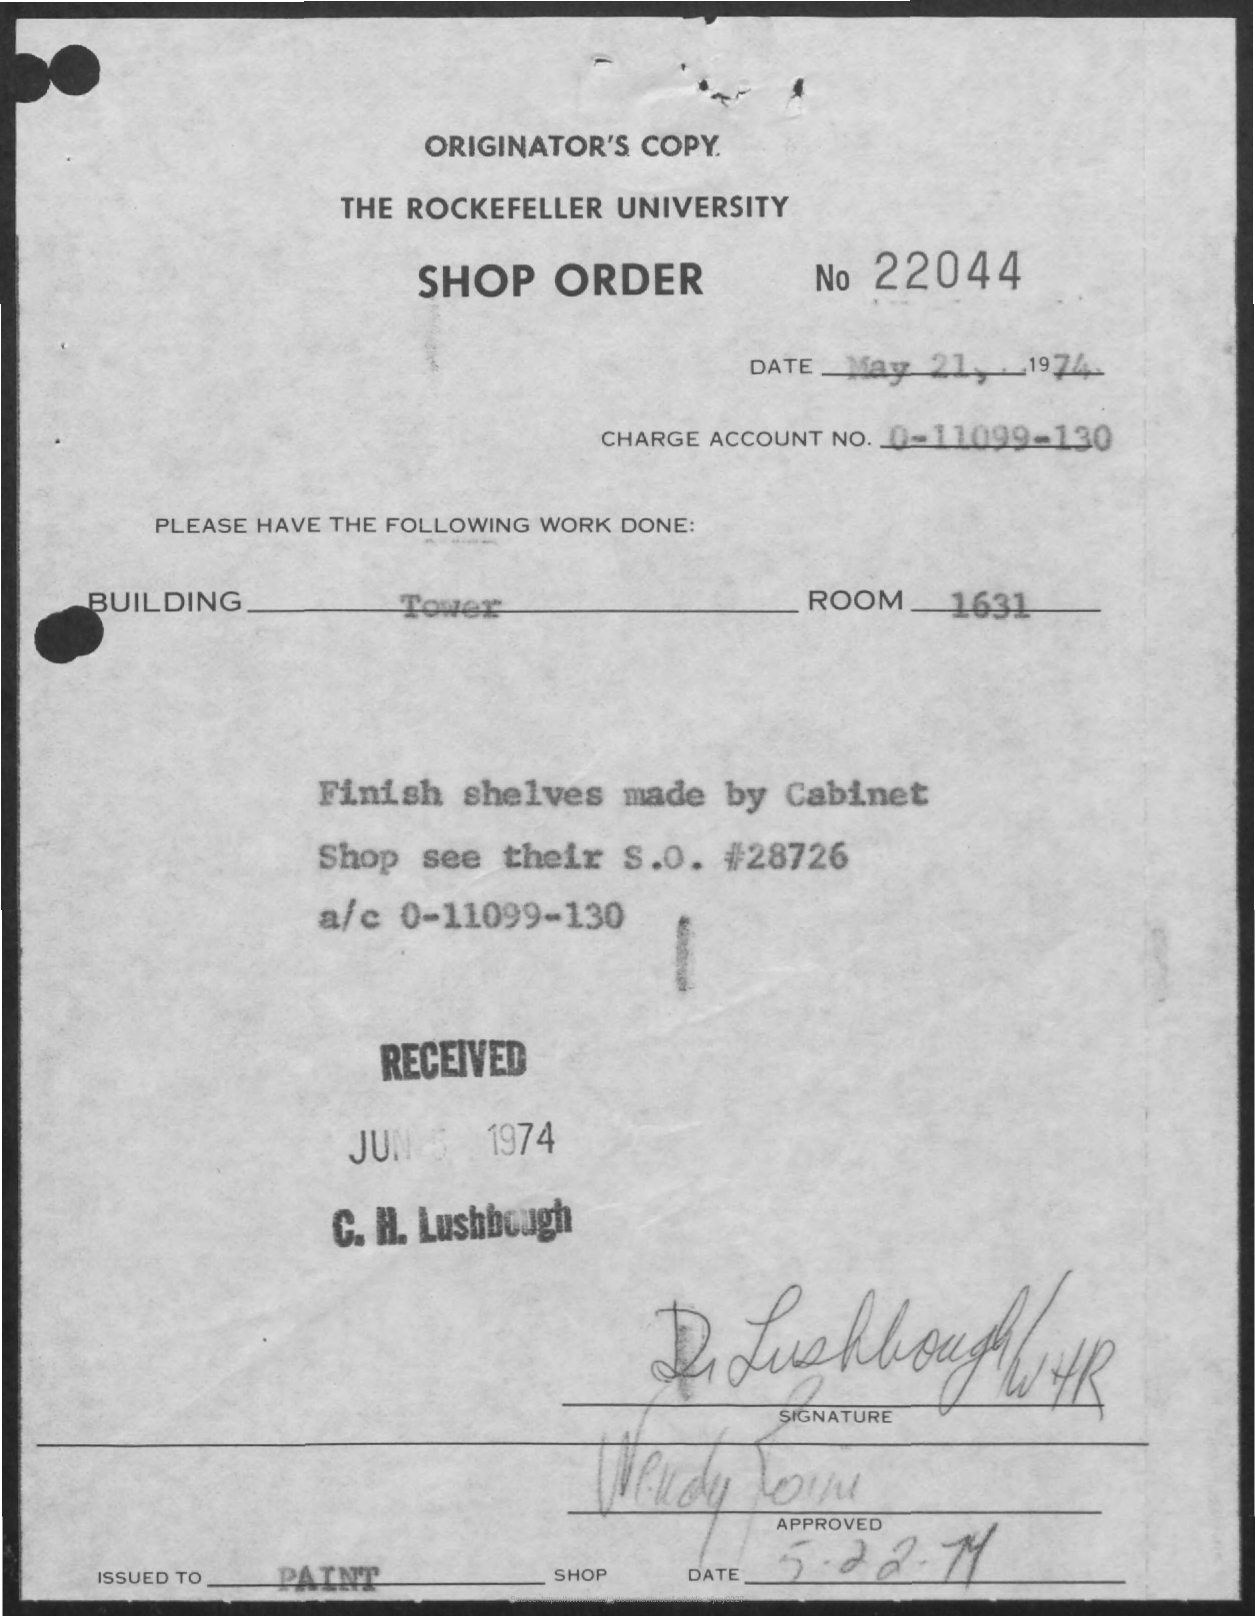What is the Charge Account Number?
Offer a very short reply. 0-11099-130. What is the Room Number?
Your response must be concise. 1631. What is the Shop order number?
Provide a succinct answer. 22044. What is the Received date mentioned in the document?
Your response must be concise. Jun 5 1974. What is the type of building?
Your response must be concise. Tower. 